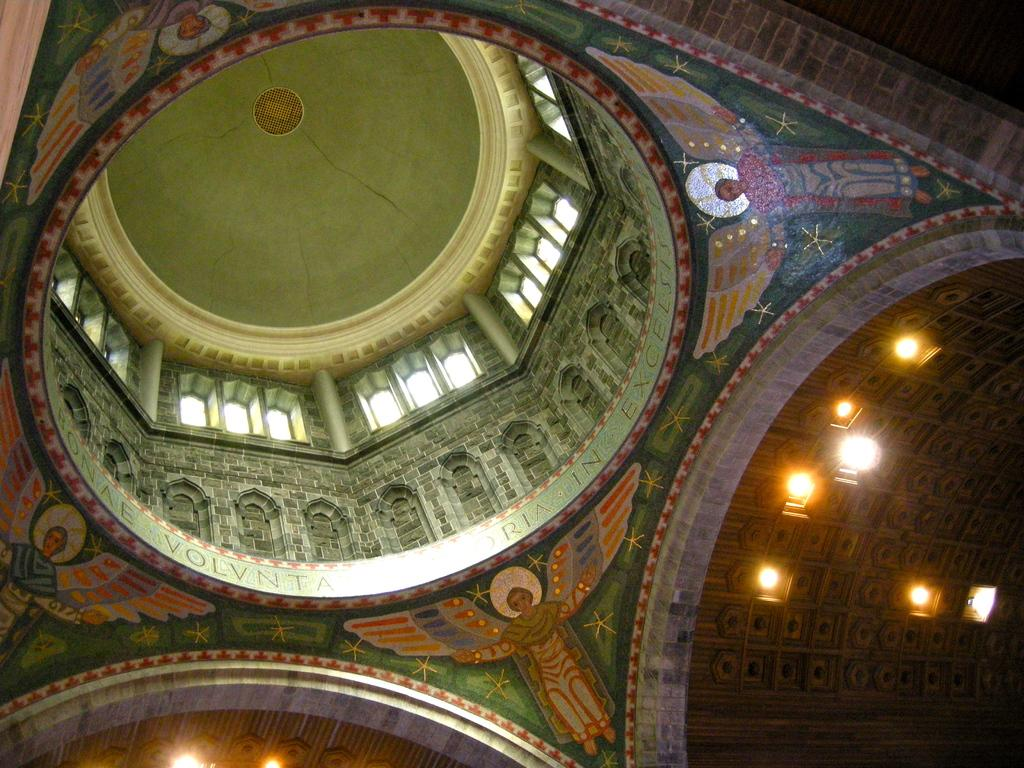What type of building is depicted in the image? The image shows a historical building. What part of the building is visible in the image? The image shows the interior view of the building's ceiling. What decorative elements can be seen in the image? There are paintings, arts, and designs on the ceiling. What can be used for illumination in the image? There are lights visible in the image. Can you describe the trail left by the giraffe in the image? There is no giraffe present in the image, so there is no trail left by a giraffe to describe. 